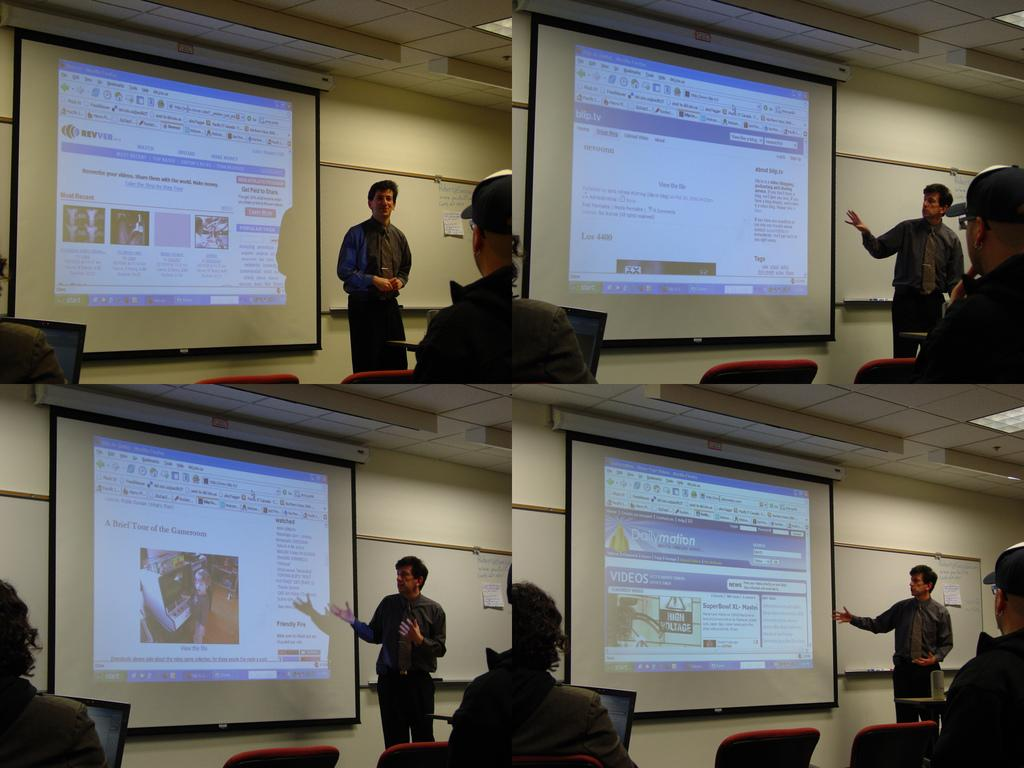What type of subjects are depicted in the pictures in the image? The pictures in the image contain pictures of people. What electronic devices are visible in the image? There are screens visible in the image. What type of furniture is present in the image? Chairs are present in the image. What type of objects can be seen on the walls in the image? There are boards on walls in the image. How many brothers are visible in the image? There is no mention of brothers in the image, as the pictures contain pictures of people in general. 